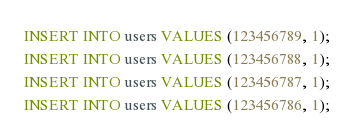Convert code to text. <code><loc_0><loc_0><loc_500><loc_500><_SQL_>INSERT INTO users VALUES (123456789, 1);
INSERT INTO users VALUES (123456788, 1);
INSERT INTO users VALUES (123456787, 1);
INSERT INTO users VALUES (123456786, 1);</code> 